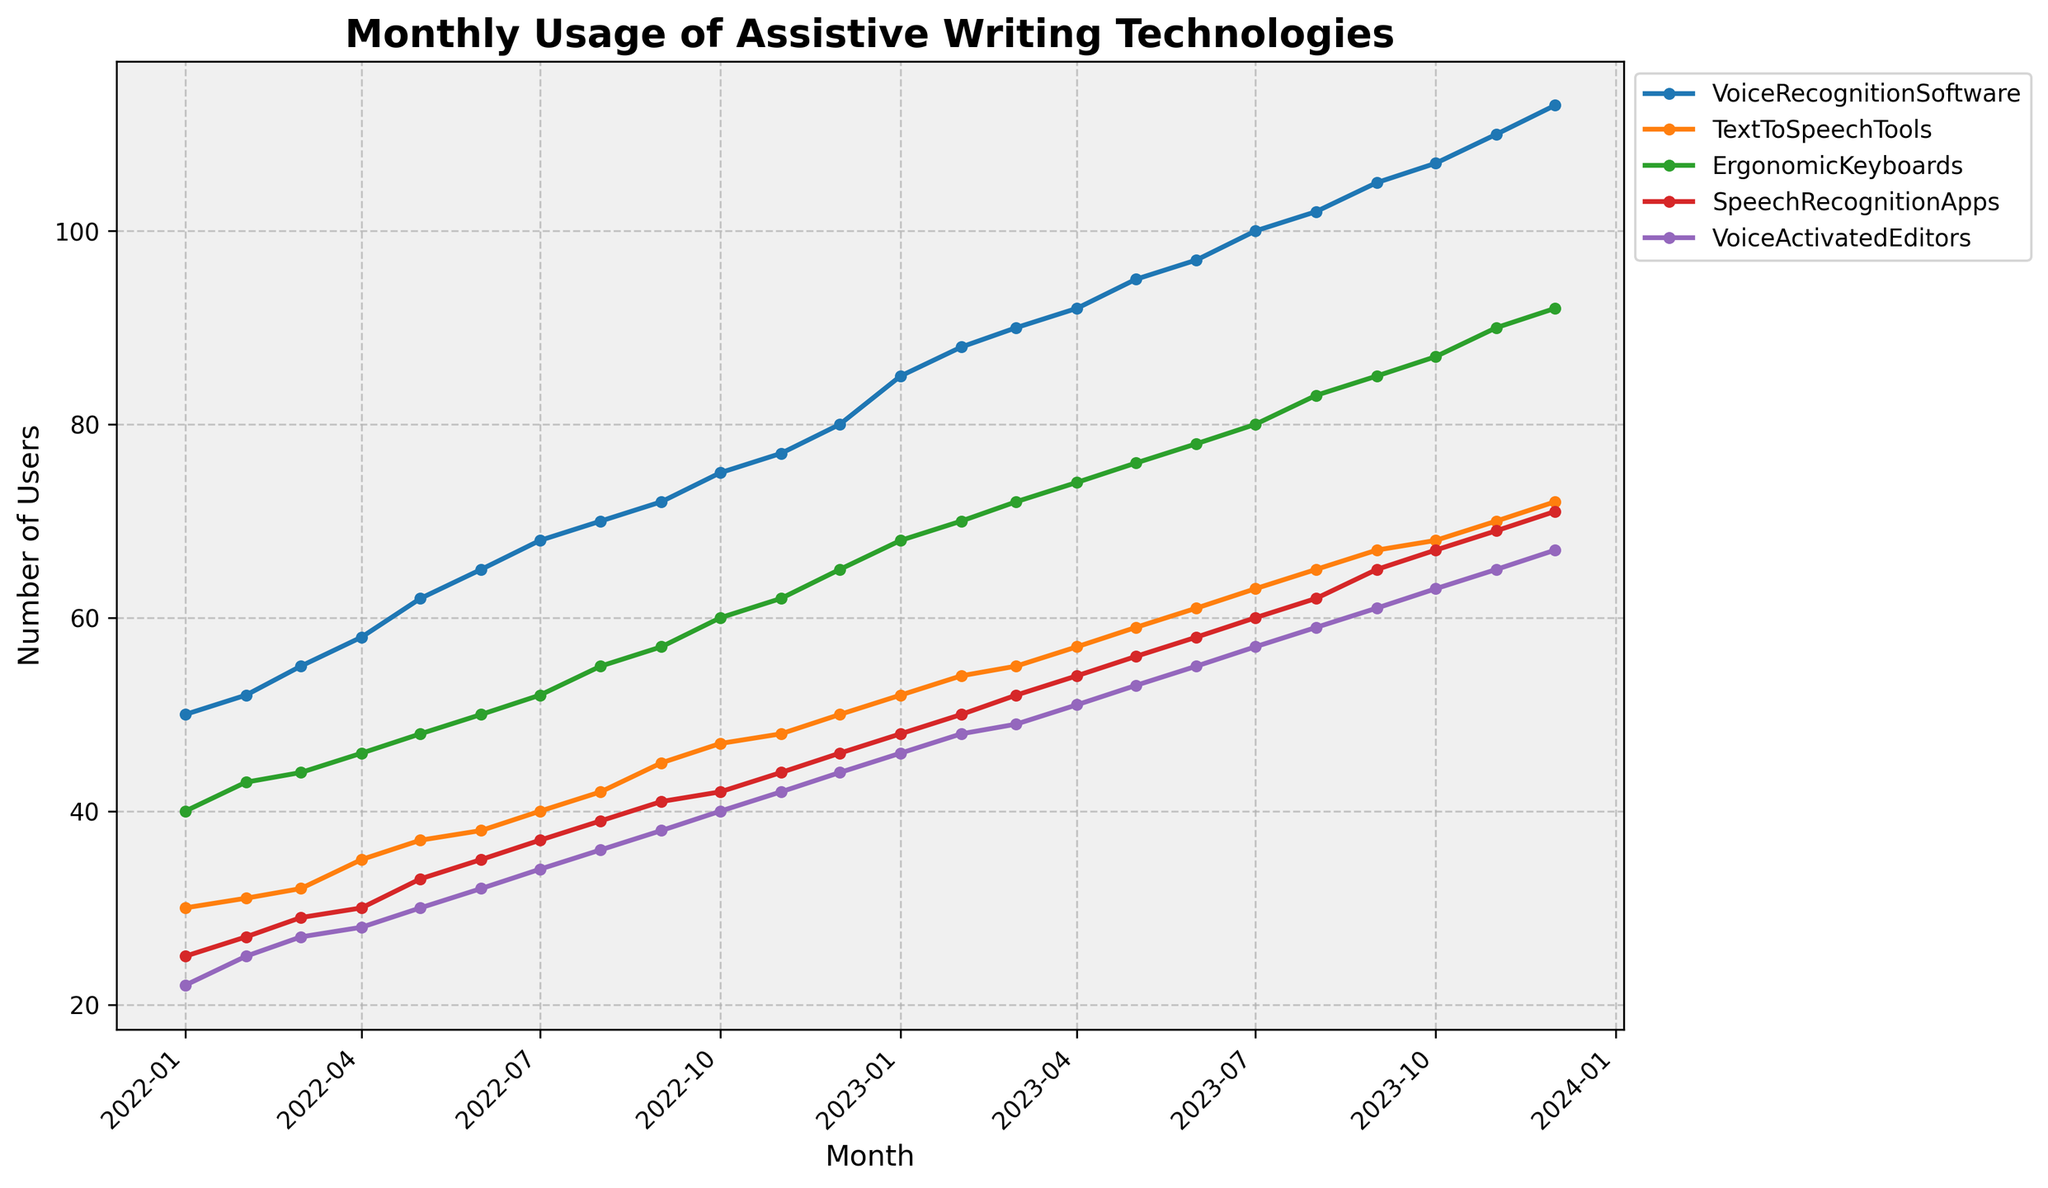what's the title of the plot? The title of the plot is located at the top center of the figure. It is displayed in bold and larger font size compared to other text elements.
Answer: Monthly Usage of Assistive Writing Technologies what is the value for VoiceRecognitionSoftware in January 2023? Locate the data point for VoiceRecognitionSoftware in January 2023 on the time series plot. Read the y-axis value corresponding to this point.
Answer: 85 which assistive technology had the highest usage in December 2023? Identify the highlighted point at December 2023 for each technology. The technology line that reaches the highest y-axis value is the one with the highest usage.
Answer: VoiceRecognitionSoftware what's the trend for SpeechRecognitionApps from January 2022 to December 2023? Observe the line representing SpeechRecognitionApps from January 2022 to December 2023. Note whether it increases, decreases, or remains constant over this period.
Answer: Increasing how many assistive technologies were plotted in the figure? Count the number of distinct lines or labels in the legend, which indicates the different assistive technologies plotted.
Answer: 5 which month shows the highest increase in users for ErgonomicKeyboards between consecutive months? Compare the y-axis values of ErgonomicKeyboards between each consecutive month and determine the month where the increase in users is the largest.
Answer: January 2023 what is the overall trend for TextToSpeechTools? Look at the line representing TextToSpeechTools from the start to the end of the time series plot and observe whether it generally increases, decreases, or remains constant.
Answer: Increasing by how many users did the usage of VoiceActivatedEditors increase from March 2022 to March 2023? Identify the y-axis values for VoiceActivatedEditors in March 2022 and March 2023, then subtract the March 2022 value from the March 2023 value.
Answer: 27 what was the growth rate of VoiceRecognitionSoftware from January 2022 to December 2023? Calculate the difference in the number of users of VoiceRecognitionSoftware between January 2022 and December 2023, then divide by the number of months (24) and multiply by 100 for the percentage.
Answer: 265% which assistive technology showed the smallest variation in user numbers over the plotted period? Examine each assistive technology line to assess the range of values on the y-axis. The technology with the smallest range has the smallest variation.
Answer: TextToSpeechTools 